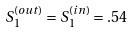<formula> <loc_0><loc_0><loc_500><loc_500>S _ { 1 } ^ { ( o u t ) } = S _ { 1 } ^ { ( i n ) } = . 5 4</formula> 